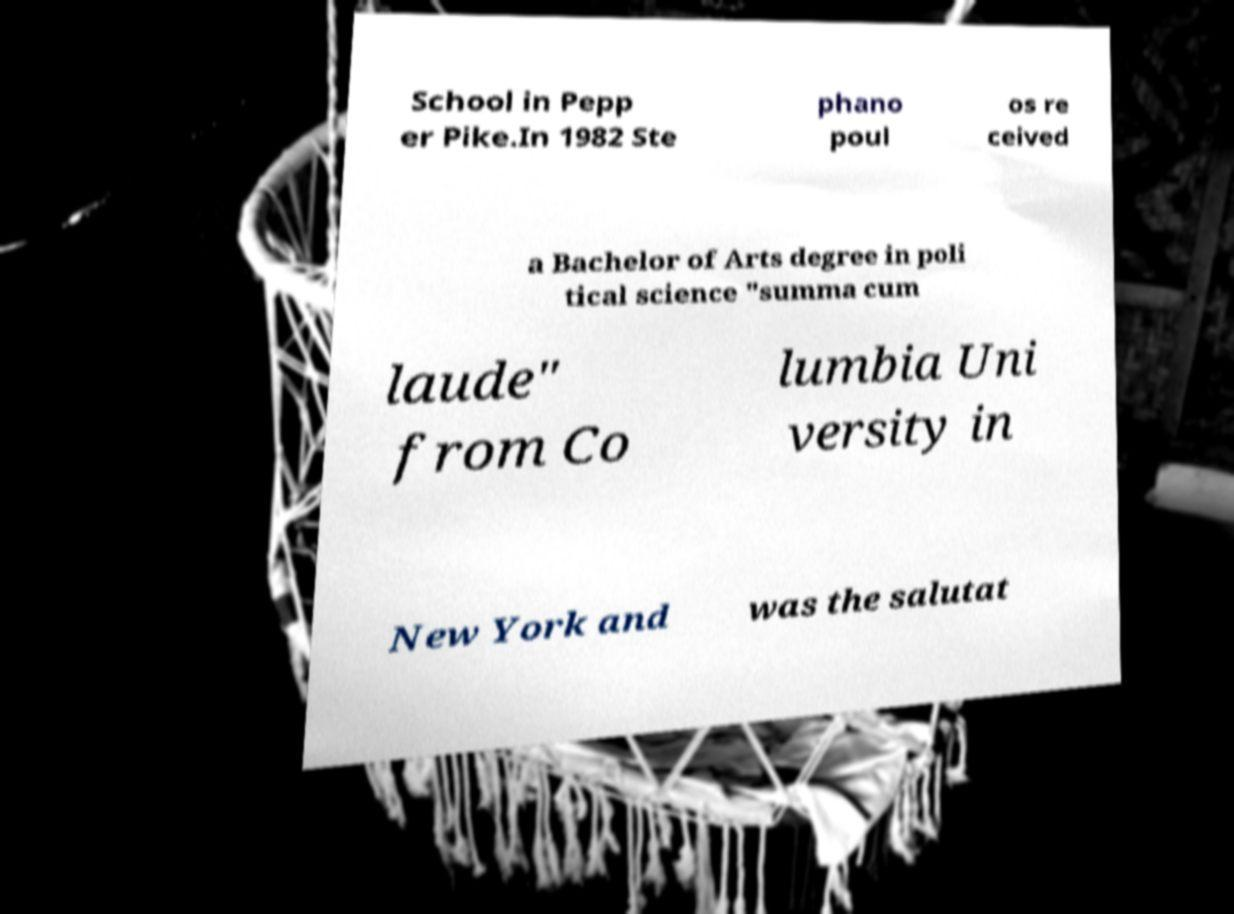Can you accurately transcribe the text from the provided image for me? School in Pepp er Pike.In 1982 Ste phano poul os re ceived a Bachelor of Arts degree in poli tical science "summa cum laude" from Co lumbia Uni versity in New York and was the salutat 